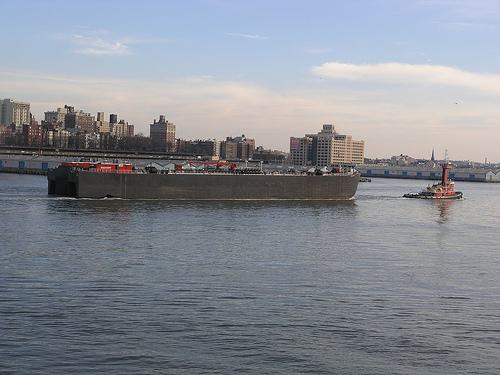Is there a boat in the image? Yes 